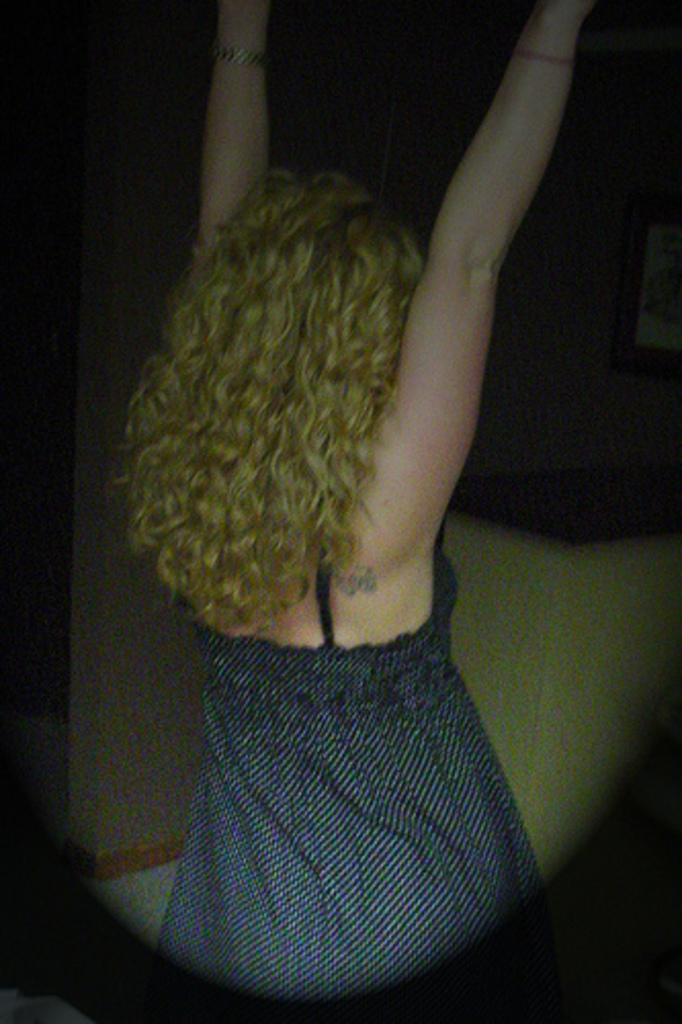How would you summarize this image in a sentence or two? In this image we can see a woman standing. On the right side of the image we can see a photo frame on the wall. 